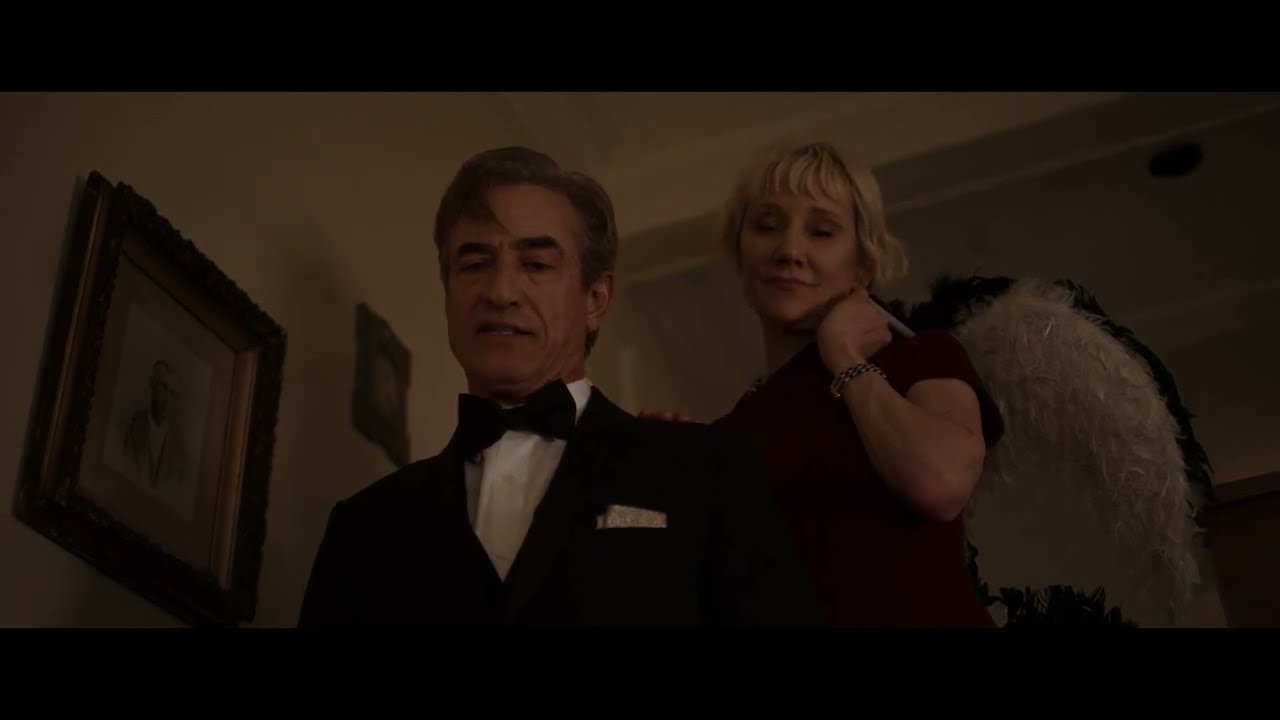What emotions do you think are being conveyed in this scene? The emotions in this scene seem to be of warmth and anticipation. The man’s composed demeanor, countered by the woman’s warm smile and elegant posture, conveys a blend of formality and friendliness. The soft lighting and the intimate setting further enhance these emotions, suggesting a meaningful and pleasant interaction between the two individuals. Can you speculate on the relationship between these two individuals based on this image? Based on the image, the relationship between these two individuals could be multifaceted. The formal attire suggests they might be attending a sophisticated event together, possibly as a couple or close acquaintances. The warm smile on the woman's face hints at familiarity and affection, indicating a deeper connection. Alternatively, they could be colleagues or friends sharing a moment of camaraderie and mutual respect. 